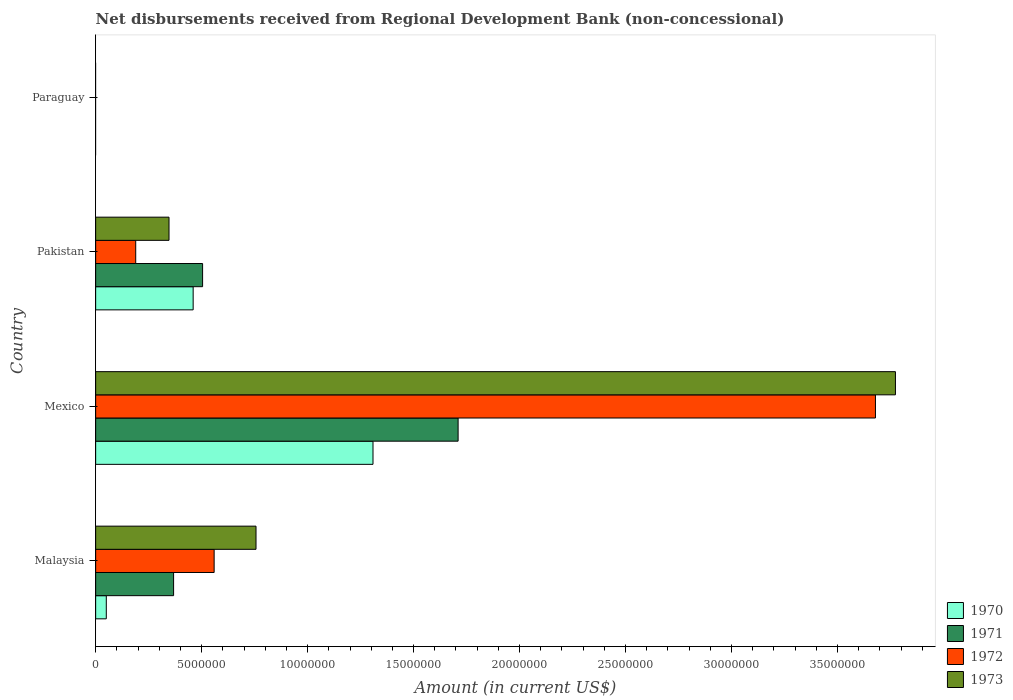Are the number of bars on each tick of the Y-axis equal?
Provide a succinct answer. No. What is the label of the 1st group of bars from the top?
Offer a very short reply. Paraguay. In how many cases, is the number of bars for a given country not equal to the number of legend labels?
Give a very brief answer. 1. What is the amount of disbursements received from Regional Development Bank in 1972 in Malaysia?
Provide a short and direct response. 5.59e+06. Across all countries, what is the maximum amount of disbursements received from Regional Development Bank in 1973?
Give a very brief answer. 3.77e+07. In which country was the amount of disbursements received from Regional Development Bank in 1973 maximum?
Offer a very short reply. Mexico. What is the total amount of disbursements received from Regional Development Bank in 1971 in the graph?
Provide a succinct answer. 2.58e+07. What is the difference between the amount of disbursements received from Regional Development Bank in 1971 in Malaysia and that in Mexico?
Offer a very short reply. -1.34e+07. What is the difference between the amount of disbursements received from Regional Development Bank in 1971 in Malaysia and the amount of disbursements received from Regional Development Bank in 1972 in Mexico?
Keep it short and to the point. -3.31e+07. What is the average amount of disbursements received from Regional Development Bank in 1970 per country?
Offer a terse response. 4.55e+06. What is the difference between the amount of disbursements received from Regional Development Bank in 1972 and amount of disbursements received from Regional Development Bank in 1973 in Mexico?
Make the answer very short. -9.43e+05. In how many countries, is the amount of disbursements received from Regional Development Bank in 1973 greater than 38000000 US$?
Your answer should be very brief. 0. What is the ratio of the amount of disbursements received from Regional Development Bank in 1971 in Mexico to that in Pakistan?
Offer a terse response. 3.39. Is the amount of disbursements received from Regional Development Bank in 1973 in Malaysia less than that in Pakistan?
Provide a short and direct response. No. What is the difference between the highest and the second highest amount of disbursements received from Regional Development Bank in 1973?
Give a very brief answer. 3.02e+07. What is the difference between the highest and the lowest amount of disbursements received from Regional Development Bank in 1971?
Offer a terse response. 1.71e+07. In how many countries, is the amount of disbursements received from Regional Development Bank in 1972 greater than the average amount of disbursements received from Regional Development Bank in 1972 taken over all countries?
Offer a terse response. 1. Is the sum of the amount of disbursements received from Regional Development Bank in 1971 in Mexico and Pakistan greater than the maximum amount of disbursements received from Regional Development Bank in 1973 across all countries?
Your answer should be very brief. No. Is it the case that in every country, the sum of the amount of disbursements received from Regional Development Bank in 1972 and amount of disbursements received from Regional Development Bank in 1973 is greater than the amount of disbursements received from Regional Development Bank in 1970?
Your answer should be very brief. No. What is the difference between two consecutive major ticks on the X-axis?
Make the answer very short. 5.00e+06. Are the values on the major ticks of X-axis written in scientific E-notation?
Keep it short and to the point. No. Does the graph contain any zero values?
Provide a short and direct response. Yes. Where does the legend appear in the graph?
Offer a very short reply. Bottom right. How many legend labels are there?
Offer a terse response. 4. What is the title of the graph?
Your answer should be compact. Net disbursements received from Regional Development Bank (non-concessional). Does "1972" appear as one of the legend labels in the graph?
Your response must be concise. Yes. What is the label or title of the X-axis?
Provide a succinct answer. Amount (in current US$). What is the Amount (in current US$) of 1970 in Malaysia?
Your answer should be very brief. 5.02e+05. What is the Amount (in current US$) in 1971 in Malaysia?
Provide a succinct answer. 3.68e+06. What is the Amount (in current US$) in 1972 in Malaysia?
Your answer should be compact. 5.59e+06. What is the Amount (in current US$) of 1973 in Malaysia?
Keep it short and to the point. 7.57e+06. What is the Amount (in current US$) in 1970 in Mexico?
Your answer should be compact. 1.31e+07. What is the Amount (in current US$) of 1971 in Mexico?
Provide a succinct answer. 1.71e+07. What is the Amount (in current US$) of 1972 in Mexico?
Give a very brief answer. 3.68e+07. What is the Amount (in current US$) of 1973 in Mexico?
Provide a short and direct response. 3.77e+07. What is the Amount (in current US$) of 1970 in Pakistan?
Provide a succinct answer. 4.60e+06. What is the Amount (in current US$) in 1971 in Pakistan?
Your answer should be compact. 5.04e+06. What is the Amount (in current US$) of 1972 in Pakistan?
Keep it short and to the point. 1.89e+06. What is the Amount (in current US$) in 1973 in Pakistan?
Keep it short and to the point. 3.46e+06. What is the Amount (in current US$) in 1970 in Paraguay?
Your response must be concise. 0. What is the Amount (in current US$) of 1971 in Paraguay?
Offer a terse response. 0. What is the Amount (in current US$) of 1972 in Paraguay?
Provide a short and direct response. 0. What is the Amount (in current US$) of 1973 in Paraguay?
Offer a very short reply. 0. Across all countries, what is the maximum Amount (in current US$) in 1970?
Offer a terse response. 1.31e+07. Across all countries, what is the maximum Amount (in current US$) in 1971?
Give a very brief answer. 1.71e+07. Across all countries, what is the maximum Amount (in current US$) in 1972?
Provide a short and direct response. 3.68e+07. Across all countries, what is the maximum Amount (in current US$) of 1973?
Keep it short and to the point. 3.77e+07. Across all countries, what is the minimum Amount (in current US$) in 1970?
Give a very brief answer. 0. Across all countries, what is the minimum Amount (in current US$) of 1972?
Provide a succinct answer. 0. Across all countries, what is the minimum Amount (in current US$) of 1973?
Provide a short and direct response. 0. What is the total Amount (in current US$) of 1970 in the graph?
Provide a short and direct response. 1.82e+07. What is the total Amount (in current US$) of 1971 in the graph?
Keep it short and to the point. 2.58e+07. What is the total Amount (in current US$) in 1972 in the graph?
Keep it short and to the point. 4.43e+07. What is the total Amount (in current US$) of 1973 in the graph?
Ensure brevity in your answer.  4.88e+07. What is the difference between the Amount (in current US$) of 1970 in Malaysia and that in Mexico?
Provide a short and direct response. -1.26e+07. What is the difference between the Amount (in current US$) in 1971 in Malaysia and that in Mexico?
Your response must be concise. -1.34e+07. What is the difference between the Amount (in current US$) of 1972 in Malaysia and that in Mexico?
Make the answer very short. -3.12e+07. What is the difference between the Amount (in current US$) in 1973 in Malaysia and that in Mexico?
Your answer should be compact. -3.02e+07. What is the difference between the Amount (in current US$) in 1970 in Malaysia and that in Pakistan?
Ensure brevity in your answer.  -4.10e+06. What is the difference between the Amount (in current US$) in 1971 in Malaysia and that in Pakistan?
Your answer should be very brief. -1.37e+06. What is the difference between the Amount (in current US$) of 1972 in Malaysia and that in Pakistan?
Provide a short and direct response. 3.70e+06. What is the difference between the Amount (in current US$) of 1973 in Malaysia and that in Pakistan?
Offer a very short reply. 4.10e+06. What is the difference between the Amount (in current US$) of 1970 in Mexico and that in Pakistan?
Your answer should be compact. 8.48e+06. What is the difference between the Amount (in current US$) in 1971 in Mexico and that in Pakistan?
Make the answer very short. 1.21e+07. What is the difference between the Amount (in current US$) of 1972 in Mexico and that in Pakistan?
Offer a very short reply. 3.49e+07. What is the difference between the Amount (in current US$) in 1973 in Mexico and that in Pakistan?
Your answer should be compact. 3.43e+07. What is the difference between the Amount (in current US$) of 1970 in Malaysia and the Amount (in current US$) of 1971 in Mexico?
Keep it short and to the point. -1.66e+07. What is the difference between the Amount (in current US$) in 1970 in Malaysia and the Amount (in current US$) in 1972 in Mexico?
Make the answer very short. -3.63e+07. What is the difference between the Amount (in current US$) of 1970 in Malaysia and the Amount (in current US$) of 1973 in Mexico?
Give a very brief answer. -3.72e+07. What is the difference between the Amount (in current US$) in 1971 in Malaysia and the Amount (in current US$) in 1972 in Mexico?
Your response must be concise. -3.31e+07. What is the difference between the Amount (in current US$) in 1971 in Malaysia and the Amount (in current US$) in 1973 in Mexico?
Your answer should be compact. -3.41e+07. What is the difference between the Amount (in current US$) in 1972 in Malaysia and the Amount (in current US$) in 1973 in Mexico?
Provide a succinct answer. -3.21e+07. What is the difference between the Amount (in current US$) in 1970 in Malaysia and the Amount (in current US$) in 1971 in Pakistan?
Your answer should be compact. -4.54e+06. What is the difference between the Amount (in current US$) of 1970 in Malaysia and the Amount (in current US$) of 1972 in Pakistan?
Your response must be concise. -1.39e+06. What is the difference between the Amount (in current US$) of 1970 in Malaysia and the Amount (in current US$) of 1973 in Pakistan?
Your response must be concise. -2.96e+06. What is the difference between the Amount (in current US$) in 1971 in Malaysia and the Amount (in current US$) in 1972 in Pakistan?
Ensure brevity in your answer.  1.79e+06. What is the difference between the Amount (in current US$) of 1971 in Malaysia and the Amount (in current US$) of 1973 in Pakistan?
Your answer should be compact. 2.16e+05. What is the difference between the Amount (in current US$) in 1972 in Malaysia and the Amount (in current US$) in 1973 in Pakistan?
Your answer should be compact. 2.13e+06. What is the difference between the Amount (in current US$) of 1970 in Mexico and the Amount (in current US$) of 1971 in Pakistan?
Give a very brief answer. 8.04e+06. What is the difference between the Amount (in current US$) of 1970 in Mexico and the Amount (in current US$) of 1972 in Pakistan?
Offer a very short reply. 1.12e+07. What is the difference between the Amount (in current US$) of 1970 in Mexico and the Amount (in current US$) of 1973 in Pakistan?
Provide a succinct answer. 9.62e+06. What is the difference between the Amount (in current US$) of 1971 in Mexico and the Amount (in current US$) of 1972 in Pakistan?
Provide a short and direct response. 1.52e+07. What is the difference between the Amount (in current US$) in 1971 in Mexico and the Amount (in current US$) in 1973 in Pakistan?
Provide a short and direct response. 1.36e+07. What is the difference between the Amount (in current US$) in 1972 in Mexico and the Amount (in current US$) in 1973 in Pakistan?
Your response must be concise. 3.33e+07. What is the average Amount (in current US$) in 1970 per country?
Give a very brief answer. 4.55e+06. What is the average Amount (in current US$) in 1971 per country?
Ensure brevity in your answer.  6.46e+06. What is the average Amount (in current US$) in 1972 per country?
Your answer should be compact. 1.11e+07. What is the average Amount (in current US$) of 1973 per country?
Ensure brevity in your answer.  1.22e+07. What is the difference between the Amount (in current US$) of 1970 and Amount (in current US$) of 1971 in Malaysia?
Keep it short and to the point. -3.18e+06. What is the difference between the Amount (in current US$) of 1970 and Amount (in current US$) of 1972 in Malaysia?
Offer a terse response. -5.09e+06. What is the difference between the Amount (in current US$) in 1970 and Amount (in current US$) in 1973 in Malaysia?
Provide a short and direct response. -7.06e+06. What is the difference between the Amount (in current US$) of 1971 and Amount (in current US$) of 1972 in Malaysia?
Offer a very short reply. -1.91e+06. What is the difference between the Amount (in current US$) of 1971 and Amount (in current US$) of 1973 in Malaysia?
Your answer should be compact. -3.89e+06. What is the difference between the Amount (in current US$) of 1972 and Amount (in current US$) of 1973 in Malaysia?
Make the answer very short. -1.98e+06. What is the difference between the Amount (in current US$) of 1970 and Amount (in current US$) of 1971 in Mexico?
Your response must be concise. -4.02e+06. What is the difference between the Amount (in current US$) in 1970 and Amount (in current US$) in 1972 in Mexico?
Your answer should be very brief. -2.37e+07. What is the difference between the Amount (in current US$) in 1970 and Amount (in current US$) in 1973 in Mexico?
Keep it short and to the point. -2.46e+07. What is the difference between the Amount (in current US$) of 1971 and Amount (in current US$) of 1972 in Mexico?
Offer a terse response. -1.97e+07. What is the difference between the Amount (in current US$) of 1971 and Amount (in current US$) of 1973 in Mexico?
Offer a very short reply. -2.06e+07. What is the difference between the Amount (in current US$) of 1972 and Amount (in current US$) of 1973 in Mexico?
Your answer should be compact. -9.43e+05. What is the difference between the Amount (in current US$) of 1970 and Amount (in current US$) of 1971 in Pakistan?
Provide a succinct answer. -4.45e+05. What is the difference between the Amount (in current US$) in 1970 and Amount (in current US$) in 1972 in Pakistan?
Provide a short and direct response. 2.71e+06. What is the difference between the Amount (in current US$) in 1970 and Amount (in current US$) in 1973 in Pakistan?
Provide a short and direct response. 1.14e+06. What is the difference between the Amount (in current US$) in 1971 and Amount (in current US$) in 1972 in Pakistan?
Offer a very short reply. 3.16e+06. What is the difference between the Amount (in current US$) of 1971 and Amount (in current US$) of 1973 in Pakistan?
Keep it short and to the point. 1.58e+06. What is the difference between the Amount (in current US$) of 1972 and Amount (in current US$) of 1973 in Pakistan?
Ensure brevity in your answer.  -1.57e+06. What is the ratio of the Amount (in current US$) in 1970 in Malaysia to that in Mexico?
Your answer should be very brief. 0.04. What is the ratio of the Amount (in current US$) of 1971 in Malaysia to that in Mexico?
Your answer should be very brief. 0.21. What is the ratio of the Amount (in current US$) of 1972 in Malaysia to that in Mexico?
Offer a very short reply. 0.15. What is the ratio of the Amount (in current US$) in 1973 in Malaysia to that in Mexico?
Make the answer very short. 0.2. What is the ratio of the Amount (in current US$) in 1970 in Malaysia to that in Pakistan?
Make the answer very short. 0.11. What is the ratio of the Amount (in current US$) in 1971 in Malaysia to that in Pakistan?
Offer a very short reply. 0.73. What is the ratio of the Amount (in current US$) of 1972 in Malaysia to that in Pakistan?
Make the answer very short. 2.96. What is the ratio of the Amount (in current US$) of 1973 in Malaysia to that in Pakistan?
Your answer should be compact. 2.19. What is the ratio of the Amount (in current US$) of 1970 in Mexico to that in Pakistan?
Keep it short and to the point. 2.84. What is the ratio of the Amount (in current US$) of 1971 in Mexico to that in Pakistan?
Make the answer very short. 3.39. What is the ratio of the Amount (in current US$) in 1972 in Mexico to that in Pakistan?
Make the answer very short. 19.47. What is the ratio of the Amount (in current US$) in 1973 in Mexico to that in Pakistan?
Make the answer very short. 10.9. What is the difference between the highest and the second highest Amount (in current US$) of 1970?
Provide a succinct answer. 8.48e+06. What is the difference between the highest and the second highest Amount (in current US$) in 1971?
Provide a short and direct response. 1.21e+07. What is the difference between the highest and the second highest Amount (in current US$) in 1972?
Offer a very short reply. 3.12e+07. What is the difference between the highest and the second highest Amount (in current US$) of 1973?
Offer a very short reply. 3.02e+07. What is the difference between the highest and the lowest Amount (in current US$) of 1970?
Keep it short and to the point. 1.31e+07. What is the difference between the highest and the lowest Amount (in current US$) of 1971?
Provide a succinct answer. 1.71e+07. What is the difference between the highest and the lowest Amount (in current US$) of 1972?
Give a very brief answer. 3.68e+07. What is the difference between the highest and the lowest Amount (in current US$) in 1973?
Ensure brevity in your answer.  3.77e+07. 